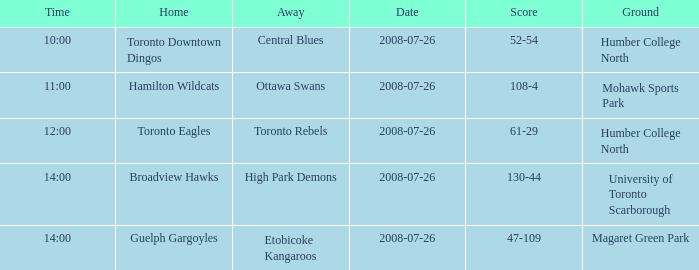With the Ground of Humber College North at 12:00, what was the Away? Toronto Rebels. 